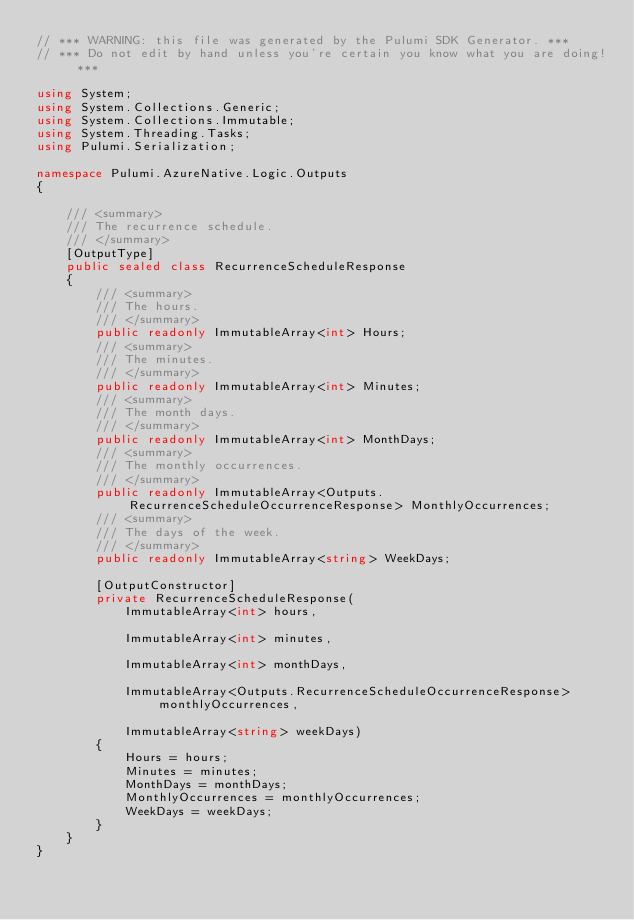Convert code to text. <code><loc_0><loc_0><loc_500><loc_500><_C#_>// *** WARNING: this file was generated by the Pulumi SDK Generator. ***
// *** Do not edit by hand unless you're certain you know what you are doing! ***

using System;
using System.Collections.Generic;
using System.Collections.Immutable;
using System.Threading.Tasks;
using Pulumi.Serialization;

namespace Pulumi.AzureNative.Logic.Outputs
{

    /// <summary>
    /// The recurrence schedule.
    /// </summary>
    [OutputType]
    public sealed class RecurrenceScheduleResponse
    {
        /// <summary>
        /// The hours.
        /// </summary>
        public readonly ImmutableArray<int> Hours;
        /// <summary>
        /// The minutes.
        /// </summary>
        public readonly ImmutableArray<int> Minutes;
        /// <summary>
        /// The month days.
        /// </summary>
        public readonly ImmutableArray<int> MonthDays;
        /// <summary>
        /// The monthly occurrences.
        /// </summary>
        public readonly ImmutableArray<Outputs.RecurrenceScheduleOccurrenceResponse> MonthlyOccurrences;
        /// <summary>
        /// The days of the week.
        /// </summary>
        public readonly ImmutableArray<string> WeekDays;

        [OutputConstructor]
        private RecurrenceScheduleResponse(
            ImmutableArray<int> hours,

            ImmutableArray<int> minutes,

            ImmutableArray<int> monthDays,

            ImmutableArray<Outputs.RecurrenceScheduleOccurrenceResponse> monthlyOccurrences,

            ImmutableArray<string> weekDays)
        {
            Hours = hours;
            Minutes = minutes;
            MonthDays = monthDays;
            MonthlyOccurrences = monthlyOccurrences;
            WeekDays = weekDays;
        }
    }
}
</code> 